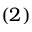<formula> <loc_0><loc_0><loc_500><loc_500>( 2 )</formula> 